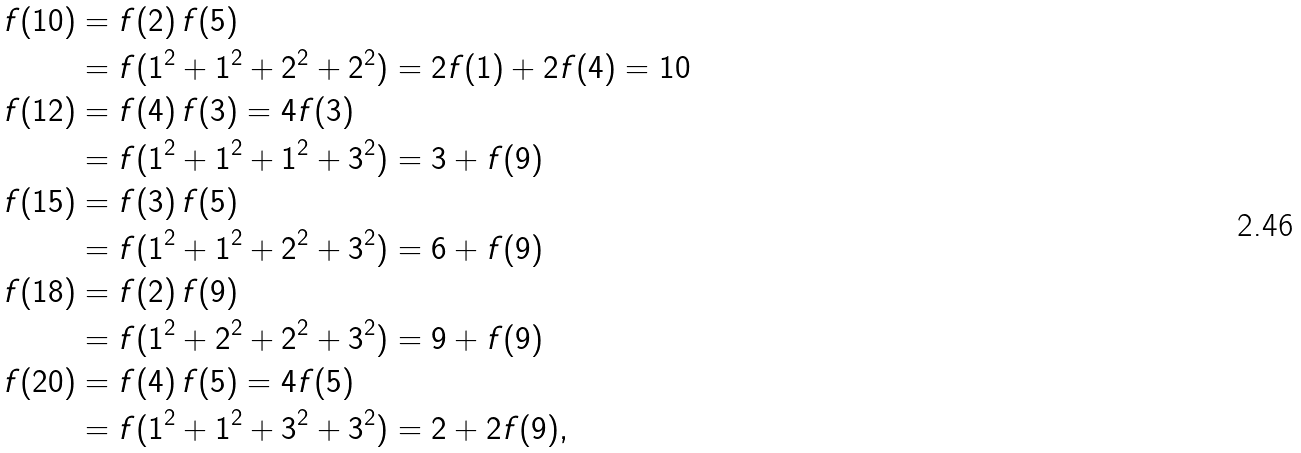Convert formula to latex. <formula><loc_0><loc_0><loc_500><loc_500>f ( 1 0 ) & = f ( 2 ) \, f ( 5 ) \\ & = f ( 1 ^ { 2 } + 1 ^ { 2 } + 2 ^ { 2 } + 2 ^ { 2 } ) = 2 f ( 1 ) + 2 f ( 4 ) = 1 0 \\ f ( 1 2 ) & = f ( 4 ) \, f ( 3 ) = 4 f ( 3 ) \\ & = f ( 1 ^ { 2 } + 1 ^ { 2 } + 1 ^ { 2 } + 3 ^ { 2 } ) = 3 + f ( 9 ) \\ f ( 1 5 ) & = f ( 3 ) \, f ( 5 ) \\ & = f ( 1 ^ { 2 } + 1 ^ { 2 } + 2 ^ { 2 } + 3 ^ { 2 } ) = 6 + f ( 9 ) \\ f ( 1 8 ) & = f ( 2 ) \, f ( 9 ) \\ & = f ( 1 ^ { 2 } + 2 ^ { 2 } + 2 ^ { 2 } + 3 ^ { 2 } ) = 9 + f ( 9 ) \\ f ( 2 0 ) & = f ( 4 ) \, f ( 5 ) = 4 f ( 5 ) \\ & = f ( 1 ^ { 2 } + 1 ^ { 2 } + 3 ^ { 2 } + 3 ^ { 2 } ) = 2 + 2 f ( 9 ) ,</formula> 